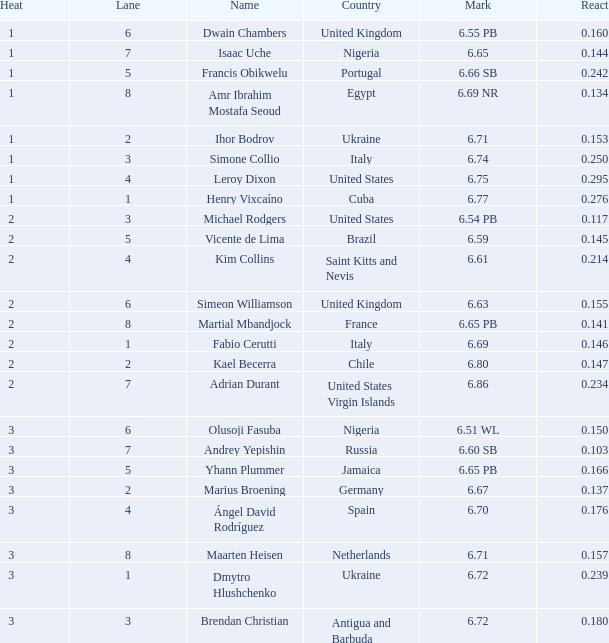Identify the country when the value of lane is 5 and react surpasses 0.166. Portugal. 